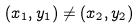Convert formula to latex. <formula><loc_0><loc_0><loc_500><loc_500>( x _ { 1 } , y _ { 1 } ) \ne ( x _ { 2 } , y _ { 2 } )</formula> 